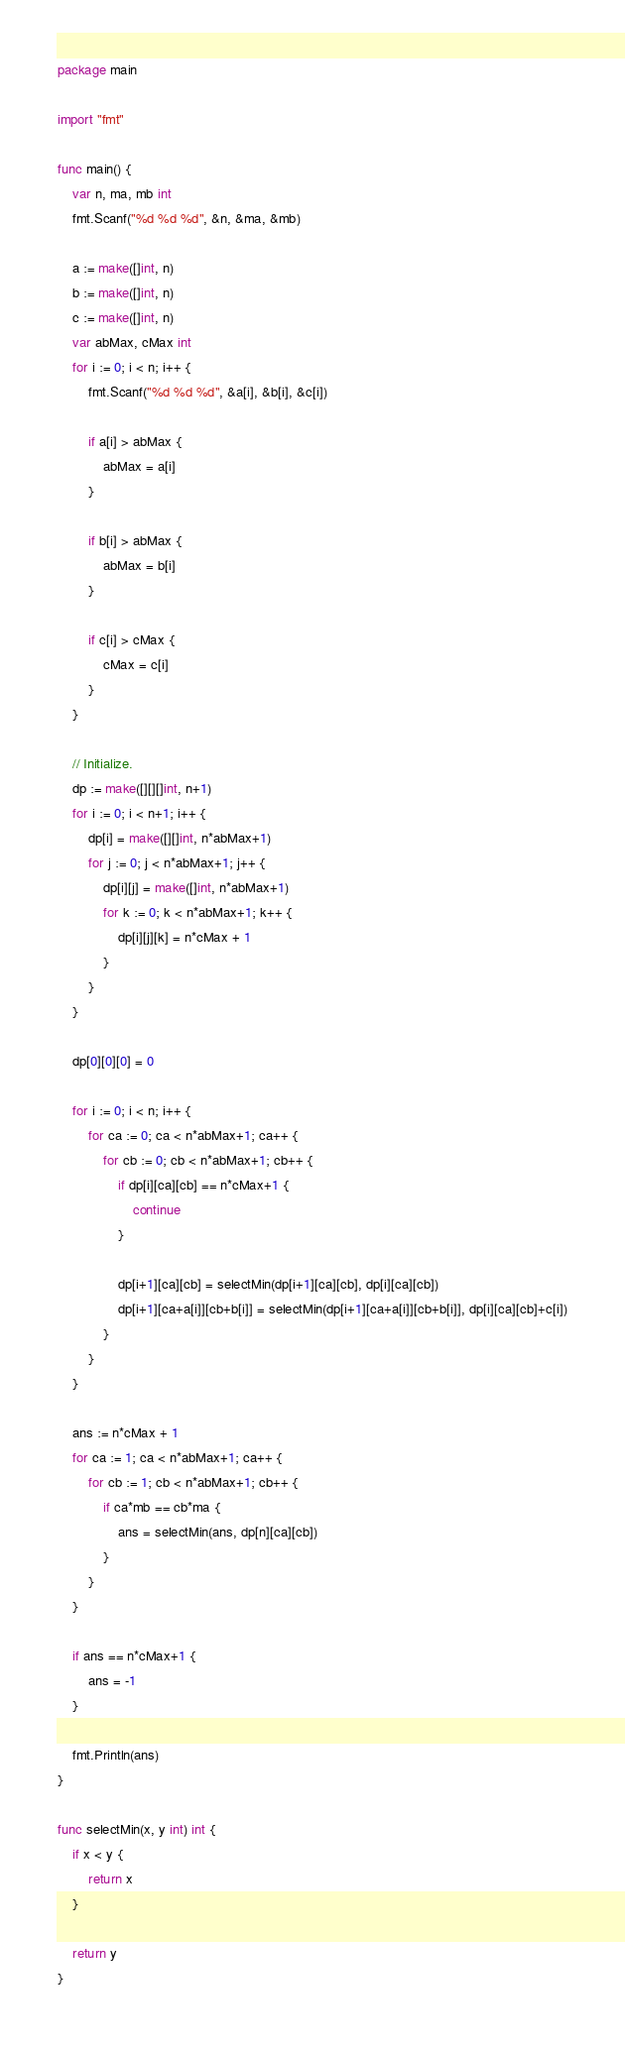<code> <loc_0><loc_0><loc_500><loc_500><_Go_>package main

import "fmt"

func main() {
	var n, ma, mb int
	fmt.Scanf("%d %d %d", &n, &ma, &mb)

	a := make([]int, n)
	b := make([]int, n)
	c := make([]int, n)
	var abMax, cMax int
	for i := 0; i < n; i++ {
		fmt.Scanf("%d %d %d", &a[i], &b[i], &c[i])

		if a[i] > abMax {
			abMax = a[i]
		}

		if b[i] > abMax {
			abMax = b[i]
		}

		if c[i] > cMax {
			cMax = c[i]
		}
	}

	// Initialize.
	dp := make([][][]int, n+1)
	for i := 0; i < n+1; i++ {
		dp[i] = make([][]int, n*abMax+1)
		for j := 0; j < n*abMax+1; j++ {
			dp[i][j] = make([]int, n*abMax+1)
			for k := 0; k < n*abMax+1; k++ {
				dp[i][j][k] = n*cMax + 1
			}
		}
	}

	dp[0][0][0] = 0

	for i := 0; i < n; i++ {
		for ca := 0; ca < n*abMax+1; ca++ {
			for cb := 0; cb < n*abMax+1; cb++ {
				if dp[i][ca][cb] == n*cMax+1 {
					continue
				}

				dp[i+1][ca][cb] = selectMin(dp[i+1][ca][cb], dp[i][ca][cb])
				dp[i+1][ca+a[i]][cb+b[i]] = selectMin(dp[i+1][ca+a[i]][cb+b[i]], dp[i][ca][cb]+c[i])
			}
		}
	}

	ans := n*cMax + 1
	for ca := 1; ca < n*abMax+1; ca++ {
		for cb := 1; cb < n*abMax+1; cb++ {
			if ca*mb == cb*ma {
				ans = selectMin(ans, dp[n][ca][cb])
			}
		}
	}

	if ans == n*cMax+1 {
		ans = -1
	}

	fmt.Println(ans)
}

func selectMin(x, y int) int {
	if x < y {
		return x
	}

	return y
}</code> 